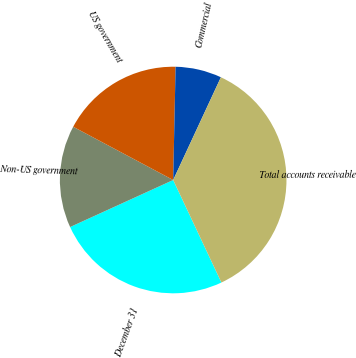Convert chart. <chart><loc_0><loc_0><loc_500><loc_500><pie_chart><fcel>December 31<fcel>Non-US government<fcel>US government<fcel>Commercial<fcel>Total accounts receivable<nl><fcel>25.19%<fcel>14.6%<fcel>17.55%<fcel>6.58%<fcel>36.08%<nl></chart> 